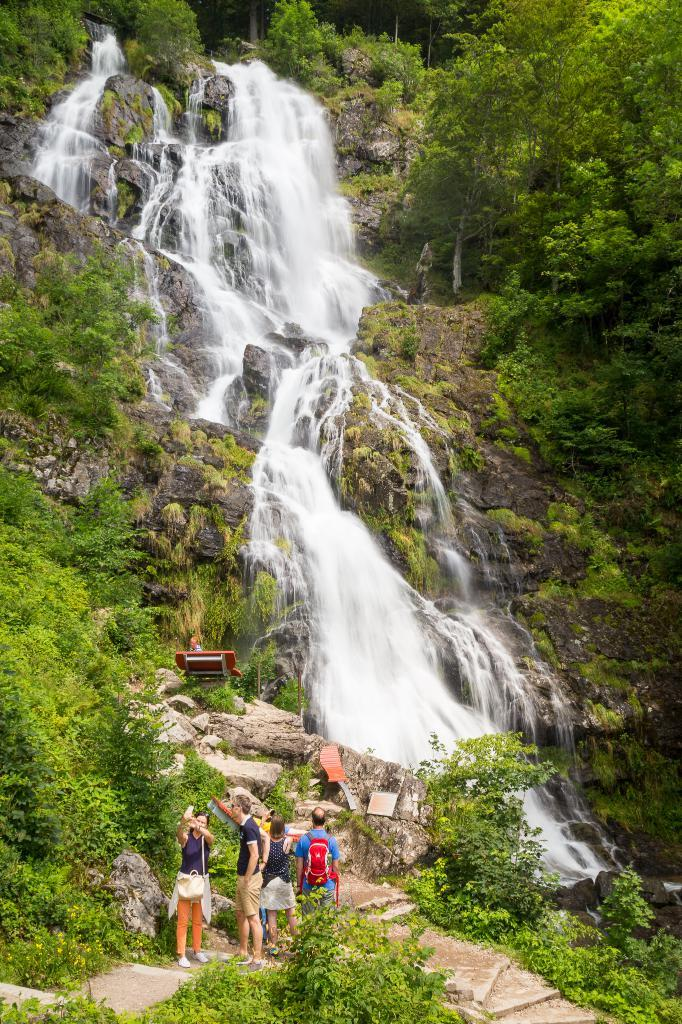What can be seen in the image involving people? There are people standing in the image. What architectural feature is present in the image? There are stairs in the image. What type of natural elements can be seen in the image? There are trees and a waterfall in the image. What type of seating is available in the image? There is a bench in the image. What type of terrain is visible in the image? There are rocks in the image. Where is the waterfall located in the image? The waterfall is located on hills in the image. Can you see any fog in the image? There is no mention of fog in the image, so it cannot be determined if it is present or not. What type of apple is being eaten by the people in the image? There is no apple present in the image, so it cannot be determined if it is being eaten or not. 